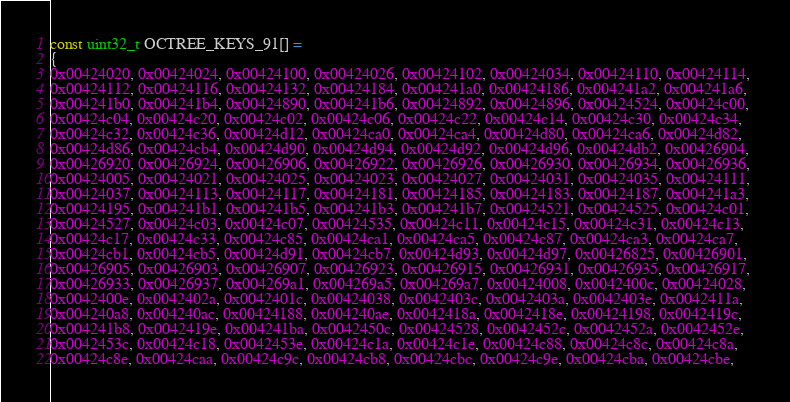<code> <loc_0><loc_0><loc_500><loc_500><_C++_>const uint32_t OCTREE_KEYS_91[] =
{
0x00424020, 0x00424024, 0x00424100, 0x00424026, 0x00424102, 0x00424034, 0x00424110, 0x00424114, 
0x00424112, 0x00424116, 0x00424132, 0x00424184, 0x004241a0, 0x00424186, 0x004241a2, 0x004241a6, 
0x004241b0, 0x004241b4, 0x00424890, 0x004241b6, 0x00424892, 0x00424896, 0x00424524, 0x00424c00, 
0x00424c04, 0x00424c20, 0x00424c02, 0x00424c06, 0x00424c22, 0x00424c14, 0x00424c30, 0x00424c34, 
0x00424c32, 0x00424c36, 0x00424d12, 0x00424ca0, 0x00424ca4, 0x00424d80, 0x00424ca6, 0x00424d82, 
0x00424d86, 0x00424cb4, 0x00424d90, 0x00424d94, 0x00424d92, 0x00424d96, 0x00424db2, 0x00426904, 
0x00426920, 0x00426924, 0x00426906, 0x00426922, 0x00426926, 0x00426930, 0x00426934, 0x00426936, 
0x00424005, 0x00424021, 0x00424025, 0x00424023, 0x00424027, 0x00424031, 0x00424035, 0x00424111, 
0x00424037, 0x00424113, 0x00424117, 0x00424181, 0x00424185, 0x00424183, 0x00424187, 0x004241a3, 
0x00424195, 0x004241b1, 0x004241b5, 0x004241b3, 0x004241b7, 0x00424521, 0x00424525, 0x00424c01, 
0x00424527, 0x00424c03, 0x00424c07, 0x00424535, 0x00424c11, 0x00424c15, 0x00424c31, 0x00424c13, 
0x00424c17, 0x00424c33, 0x00424c85, 0x00424ca1, 0x00424ca5, 0x00424c87, 0x00424ca3, 0x00424ca7, 
0x00424cb1, 0x00424cb5, 0x00424d91, 0x00424cb7, 0x00424d93, 0x00424d97, 0x00426825, 0x00426901, 
0x00426905, 0x00426903, 0x00426907, 0x00426923, 0x00426915, 0x00426931, 0x00426935, 0x00426917, 
0x00426933, 0x00426937, 0x004269a1, 0x004269a5, 0x004269a7, 0x00424008, 0x0042400c, 0x00424028, 
0x0042400e, 0x0042402a, 0x0042401c, 0x00424038, 0x0042403c, 0x0042403a, 0x0042403e, 0x0042411a, 
0x004240a8, 0x004240ac, 0x00424188, 0x004240ae, 0x0042418a, 0x0042418e, 0x00424198, 0x0042419c, 
0x004241b8, 0x0042419e, 0x004241ba, 0x0042450c, 0x00424528, 0x0042452c, 0x0042452a, 0x0042452e, 
0x0042453c, 0x00424c18, 0x0042453e, 0x00424c1a, 0x00424c1e, 0x00424c88, 0x00424c8c, 0x00424c8a, 
0x00424c8e, 0x00424caa, 0x00424c9c, 0x00424cb8, 0x00424cbc, 0x00424c9e, 0x00424cba, 0x00424cbe, </code> 